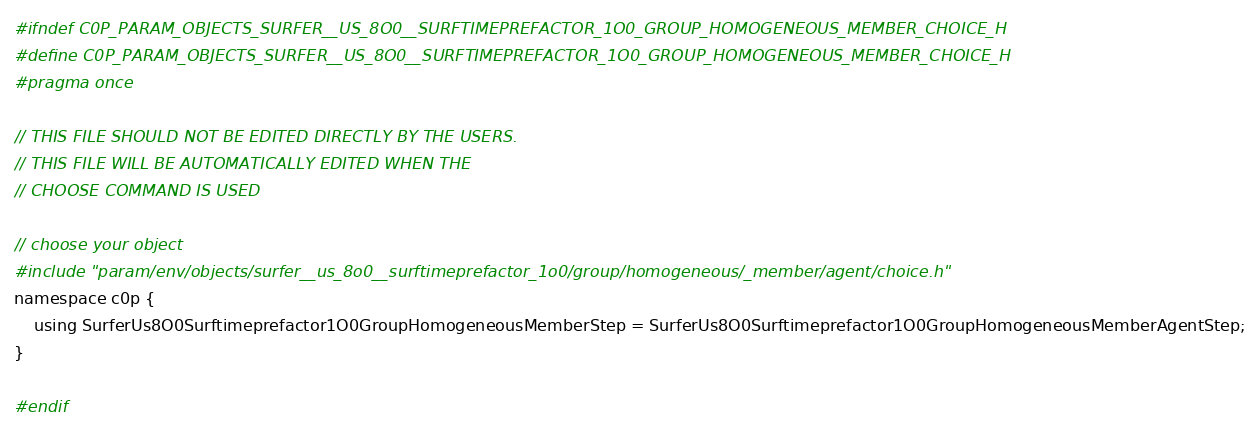<code> <loc_0><loc_0><loc_500><loc_500><_C_>#ifndef C0P_PARAM_OBJECTS_SURFER__US_8O0__SURFTIMEPREFACTOR_1O0_GROUP_HOMOGENEOUS_MEMBER_CHOICE_H
#define C0P_PARAM_OBJECTS_SURFER__US_8O0__SURFTIMEPREFACTOR_1O0_GROUP_HOMOGENEOUS_MEMBER_CHOICE_H
#pragma once

// THIS FILE SHOULD NOT BE EDITED DIRECTLY BY THE USERS.
// THIS FILE WILL BE AUTOMATICALLY EDITED WHEN THE
// CHOOSE COMMAND IS USED

// choose your object
#include "param/env/objects/surfer__us_8o0__surftimeprefactor_1o0/group/homogeneous/_member/agent/choice.h"
namespace c0p {
    using SurferUs8O0Surftimeprefactor1O0GroupHomogeneousMemberStep = SurferUs8O0Surftimeprefactor1O0GroupHomogeneousMemberAgentStep;
}

#endif
</code> 